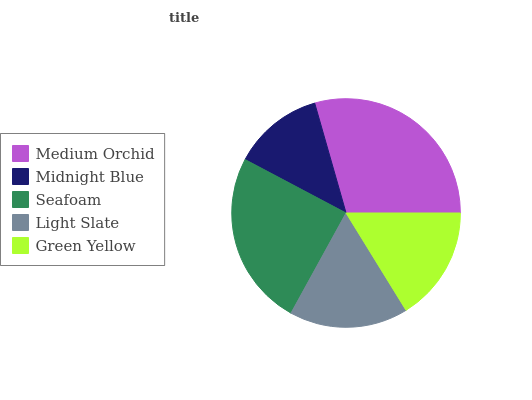Is Midnight Blue the minimum?
Answer yes or no. Yes. Is Medium Orchid the maximum?
Answer yes or no. Yes. Is Seafoam the minimum?
Answer yes or no. No. Is Seafoam the maximum?
Answer yes or no. No. Is Seafoam greater than Midnight Blue?
Answer yes or no. Yes. Is Midnight Blue less than Seafoam?
Answer yes or no. Yes. Is Midnight Blue greater than Seafoam?
Answer yes or no. No. Is Seafoam less than Midnight Blue?
Answer yes or no. No. Is Light Slate the high median?
Answer yes or no. Yes. Is Light Slate the low median?
Answer yes or no. Yes. Is Midnight Blue the high median?
Answer yes or no. No. Is Medium Orchid the low median?
Answer yes or no. No. 